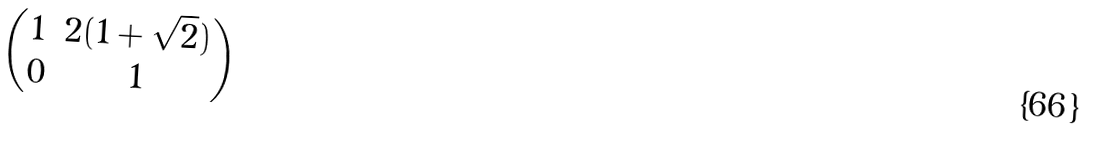<formula> <loc_0><loc_0><loc_500><loc_500>\begin{pmatrix} 1 & 2 ( 1 + \sqrt { 2 } ) \\ 0 & 1 \end{pmatrix}</formula> 